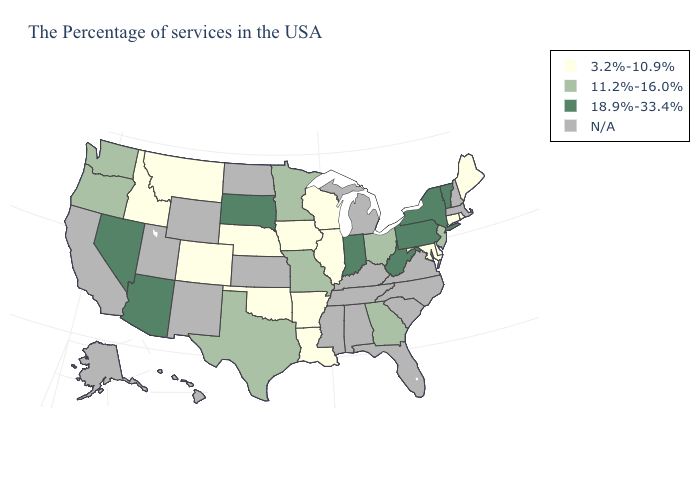How many symbols are there in the legend?
Be succinct. 4. Does Louisiana have the lowest value in the South?
Be succinct. Yes. What is the value of Vermont?
Keep it brief. 18.9%-33.4%. Which states have the highest value in the USA?
Write a very short answer. Vermont, New York, Pennsylvania, West Virginia, Indiana, South Dakota, Arizona, Nevada. Among the states that border Louisiana , does Texas have the lowest value?
Answer briefly. No. What is the value of Mississippi?
Concise answer only. N/A. Among the states that border Iowa , does Illinois have the highest value?
Keep it brief. No. What is the highest value in states that border Connecticut?
Answer briefly. 18.9%-33.4%. Does the map have missing data?
Short answer required. Yes. Name the states that have a value in the range 3.2%-10.9%?
Give a very brief answer. Maine, Rhode Island, Connecticut, Delaware, Maryland, Wisconsin, Illinois, Louisiana, Arkansas, Iowa, Nebraska, Oklahoma, Colorado, Montana, Idaho. Is the legend a continuous bar?
Answer briefly. No. What is the lowest value in the USA?
Quick response, please. 3.2%-10.9%. What is the value of Nevada?
Quick response, please. 18.9%-33.4%. 